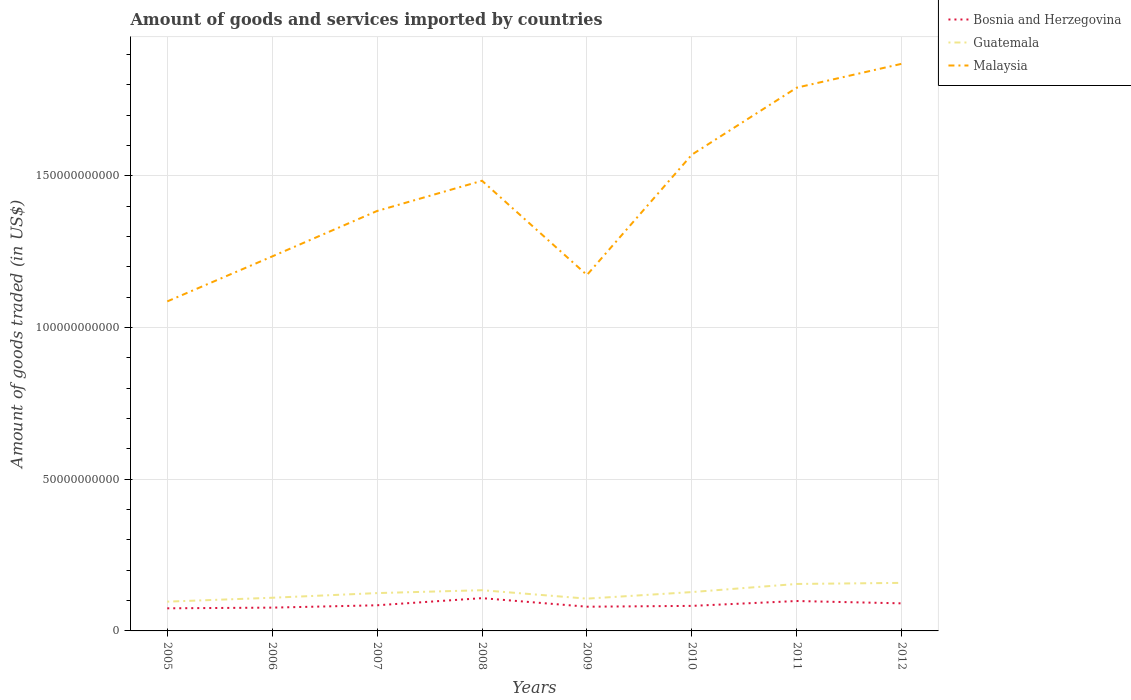Does the line corresponding to Malaysia intersect with the line corresponding to Guatemala?
Provide a short and direct response. No. Is the number of lines equal to the number of legend labels?
Give a very brief answer. Yes. Across all years, what is the maximum total amount of goods and services imported in Guatemala?
Your response must be concise. 9.65e+09. What is the total total amount of goods and services imported in Bosnia and Herzegovina in the graph?
Your answer should be compact. -1.40e+09. What is the difference between the highest and the second highest total amount of goods and services imported in Bosnia and Herzegovina?
Give a very brief answer. 3.35e+09. What is the difference between the highest and the lowest total amount of goods and services imported in Bosnia and Herzegovina?
Your response must be concise. 3. How many lines are there?
Ensure brevity in your answer.  3. How many years are there in the graph?
Offer a terse response. 8. What is the difference between two consecutive major ticks on the Y-axis?
Offer a very short reply. 5.00e+1. Does the graph contain grids?
Provide a short and direct response. Yes. How are the legend labels stacked?
Give a very brief answer. Vertical. What is the title of the graph?
Your answer should be very brief. Amount of goods and services imported by countries. Does "Gambia, The" appear as one of the legend labels in the graph?
Provide a short and direct response. No. What is the label or title of the X-axis?
Keep it short and to the point. Years. What is the label or title of the Y-axis?
Ensure brevity in your answer.  Amount of goods traded (in US$). What is the Amount of goods traded (in US$) in Bosnia and Herzegovina in 2005?
Provide a short and direct response. 7.45e+09. What is the Amount of goods traded (in US$) in Guatemala in 2005?
Offer a very short reply. 9.65e+09. What is the Amount of goods traded (in US$) of Malaysia in 2005?
Provide a short and direct response. 1.09e+11. What is the Amount of goods traded (in US$) in Bosnia and Herzegovina in 2006?
Give a very brief answer. 7.68e+09. What is the Amount of goods traded (in US$) of Guatemala in 2006?
Your response must be concise. 1.09e+1. What is the Amount of goods traded (in US$) in Malaysia in 2006?
Offer a very short reply. 1.23e+11. What is the Amount of goods traded (in US$) of Bosnia and Herzegovina in 2007?
Offer a terse response. 8.45e+09. What is the Amount of goods traded (in US$) of Guatemala in 2007?
Provide a succinct answer. 1.25e+1. What is the Amount of goods traded (in US$) of Malaysia in 2007?
Your response must be concise. 1.38e+11. What is the Amount of goods traded (in US$) in Bosnia and Herzegovina in 2008?
Offer a terse response. 1.08e+1. What is the Amount of goods traded (in US$) in Guatemala in 2008?
Your answer should be very brief. 1.34e+1. What is the Amount of goods traded (in US$) in Malaysia in 2008?
Offer a terse response. 1.48e+11. What is the Amount of goods traded (in US$) in Bosnia and Herzegovina in 2009?
Provide a short and direct response. 7.98e+09. What is the Amount of goods traded (in US$) of Guatemala in 2009?
Your response must be concise. 1.06e+1. What is the Amount of goods traded (in US$) of Malaysia in 2009?
Your answer should be very brief. 1.17e+11. What is the Amount of goods traded (in US$) of Bosnia and Herzegovina in 2010?
Offer a very short reply. 8.25e+09. What is the Amount of goods traded (in US$) in Guatemala in 2010?
Ensure brevity in your answer.  1.28e+1. What is the Amount of goods traded (in US$) of Malaysia in 2010?
Your response must be concise. 1.57e+11. What is the Amount of goods traded (in US$) of Bosnia and Herzegovina in 2011?
Provide a short and direct response. 9.86e+09. What is the Amount of goods traded (in US$) of Guatemala in 2011?
Provide a succinct answer. 1.55e+1. What is the Amount of goods traded (in US$) in Malaysia in 2011?
Your response must be concise. 1.79e+11. What is the Amount of goods traded (in US$) in Bosnia and Herzegovina in 2012?
Offer a very short reply. 9.09e+09. What is the Amount of goods traded (in US$) in Guatemala in 2012?
Ensure brevity in your answer.  1.58e+1. What is the Amount of goods traded (in US$) in Malaysia in 2012?
Provide a short and direct response. 1.87e+11. Across all years, what is the maximum Amount of goods traded (in US$) of Bosnia and Herzegovina?
Provide a short and direct response. 1.08e+1. Across all years, what is the maximum Amount of goods traded (in US$) in Guatemala?
Ensure brevity in your answer.  1.58e+1. Across all years, what is the maximum Amount of goods traded (in US$) of Malaysia?
Keep it short and to the point. 1.87e+11. Across all years, what is the minimum Amount of goods traded (in US$) in Bosnia and Herzegovina?
Provide a short and direct response. 7.45e+09. Across all years, what is the minimum Amount of goods traded (in US$) of Guatemala?
Offer a very short reply. 9.65e+09. Across all years, what is the minimum Amount of goods traded (in US$) of Malaysia?
Keep it short and to the point. 1.09e+11. What is the total Amount of goods traded (in US$) in Bosnia and Herzegovina in the graph?
Ensure brevity in your answer.  6.96e+1. What is the total Amount of goods traded (in US$) of Guatemala in the graph?
Make the answer very short. 1.01e+11. What is the total Amount of goods traded (in US$) of Malaysia in the graph?
Your answer should be very brief. 1.16e+12. What is the difference between the Amount of goods traded (in US$) in Bosnia and Herzegovina in 2005 and that in 2006?
Your answer should be compact. -2.25e+08. What is the difference between the Amount of goods traded (in US$) in Guatemala in 2005 and that in 2006?
Your response must be concise. -1.28e+09. What is the difference between the Amount of goods traded (in US$) of Malaysia in 2005 and that in 2006?
Offer a very short reply. -1.48e+1. What is the difference between the Amount of goods traded (in US$) of Bosnia and Herzegovina in 2005 and that in 2007?
Offer a terse response. -1.00e+09. What is the difference between the Amount of goods traded (in US$) in Guatemala in 2005 and that in 2007?
Offer a very short reply. -2.82e+09. What is the difference between the Amount of goods traded (in US$) in Malaysia in 2005 and that in 2007?
Offer a very short reply. -2.98e+1. What is the difference between the Amount of goods traded (in US$) in Bosnia and Herzegovina in 2005 and that in 2008?
Give a very brief answer. -3.35e+09. What is the difference between the Amount of goods traded (in US$) in Guatemala in 2005 and that in 2008?
Your response must be concise. -3.77e+09. What is the difference between the Amount of goods traded (in US$) in Malaysia in 2005 and that in 2008?
Ensure brevity in your answer.  -3.98e+1. What is the difference between the Amount of goods traded (in US$) of Bosnia and Herzegovina in 2005 and that in 2009?
Your answer should be very brief. -5.30e+08. What is the difference between the Amount of goods traded (in US$) of Guatemala in 2005 and that in 2009?
Make the answer very short. -9.93e+08. What is the difference between the Amount of goods traded (in US$) in Malaysia in 2005 and that in 2009?
Offer a very short reply. -8.71e+09. What is the difference between the Amount of goods traded (in US$) in Bosnia and Herzegovina in 2005 and that in 2010?
Ensure brevity in your answer.  -7.99e+08. What is the difference between the Amount of goods traded (in US$) of Guatemala in 2005 and that in 2010?
Provide a succinct answer. -3.16e+09. What is the difference between the Amount of goods traded (in US$) of Malaysia in 2005 and that in 2010?
Provide a short and direct response. -4.84e+1. What is the difference between the Amount of goods traded (in US$) in Bosnia and Herzegovina in 2005 and that in 2011?
Ensure brevity in your answer.  -2.40e+09. What is the difference between the Amount of goods traded (in US$) in Guatemala in 2005 and that in 2011?
Your response must be concise. -5.83e+09. What is the difference between the Amount of goods traded (in US$) in Malaysia in 2005 and that in 2011?
Ensure brevity in your answer.  -7.05e+1. What is the difference between the Amount of goods traded (in US$) of Bosnia and Herzegovina in 2005 and that in 2012?
Offer a terse response. -1.63e+09. What is the difference between the Amount of goods traded (in US$) in Guatemala in 2005 and that in 2012?
Your response must be concise. -6.19e+09. What is the difference between the Amount of goods traded (in US$) in Malaysia in 2005 and that in 2012?
Provide a short and direct response. -7.83e+1. What is the difference between the Amount of goods traded (in US$) in Bosnia and Herzegovina in 2006 and that in 2007?
Make the answer very short. -7.75e+08. What is the difference between the Amount of goods traded (in US$) of Guatemala in 2006 and that in 2007?
Ensure brevity in your answer.  -1.54e+09. What is the difference between the Amount of goods traded (in US$) in Malaysia in 2006 and that in 2007?
Your answer should be very brief. -1.50e+1. What is the difference between the Amount of goods traded (in US$) in Bosnia and Herzegovina in 2006 and that in 2008?
Keep it short and to the point. -3.12e+09. What is the difference between the Amount of goods traded (in US$) of Guatemala in 2006 and that in 2008?
Your answer should be very brief. -2.49e+09. What is the difference between the Amount of goods traded (in US$) in Malaysia in 2006 and that in 2008?
Provide a short and direct response. -2.49e+1. What is the difference between the Amount of goods traded (in US$) of Bosnia and Herzegovina in 2006 and that in 2009?
Offer a terse response. -3.05e+08. What is the difference between the Amount of goods traded (in US$) of Guatemala in 2006 and that in 2009?
Offer a terse response. 2.91e+08. What is the difference between the Amount of goods traded (in US$) in Malaysia in 2006 and that in 2009?
Make the answer very short. 6.12e+09. What is the difference between the Amount of goods traded (in US$) in Bosnia and Herzegovina in 2006 and that in 2010?
Offer a terse response. -5.74e+08. What is the difference between the Amount of goods traded (in US$) of Guatemala in 2006 and that in 2010?
Your response must be concise. -1.87e+09. What is the difference between the Amount of goods traded (in US$) in Malaysia in 2006 and that in 2010?
Make the answer very short. -3.36e+1. What is the difference between the Amount of goods traded (in US$) in Bosnia and Herzegovina in 2006 and that in 2011?
Keep it short and to the point. -2.18e+09. What is the difference between the Amount of goods traded (in US$) in Guatemala in 2006 and that in 2011?
Offer a very short reply. -4.55e+09. What is the difference between the Amount of goods traded (in US$) of Malaysia in 2006 and that in 2011?
Provide a succinct answer. -5.56e+1. What is the difference between the Amount of goods traded (in US$) of Bosnia and Herzegovina in 2006 and that in 2012?
Offer a very short reply. -1.41e+09. What is the difference between the Amount of goods traded (in US$) of Guatemala in 2006 and that in 2012?
Your answer should be compact. -4.90e+09. What is the difference between the Amount of goods traded (in US$) of Malaysia in 2006 and that in 2012?
Offer a terse response. -6.35e+1. What is the difference between the Amount of goods traded (in US$) of Bosnia and Herzegovina in 2007 and that in 2008?
Provide a succinct answer. -2.35e+09. What is the difference between the Amount of goods traded (in US$) of Guatemala in 2007 and that in 2008?
Make the answer very short. -9.51e+08. What is the difference between the Amount of goods traded (in US$) in Malaysia in 2007 and that in 2008?
Your answer should be compact. -9.96e+09. What is the difference between the Amount of goods traded (in US$) of Bosnia and Herzegovina in 2007 and that in 2009?
Offer a very short reply. 4.70e+08. What is the difference between the Amount of goods traded (in US$) in Guatemala in 2007 and that in 2009?
Provide a short and direct response. 1.83e+09. What is the difference between the Amount of goods traded (in US$) in Malaysia in 2007 and that in 2009?
Your response must be concise. 2.11e+1. What is the difference between the Amount of goods traded (in US$) of Bosnia and Herzegovina in 2007 and that in 2010?
Your answer should be compact. 2.01e+08. What is the difference between the Amount of goods traded (in US$) in Guatemala in 2007 and that in 2010?
Provide a succinct answer. -3.36e+08. What is the difference between the Amount of goods traded (in US$) in Malaysia in 2007 and that in 2010?
Provide a short and direct response. -1.86e+1. What is the difference between the Amount of goods traded (in US$) in Bosnia and Herzegovina in 2007 and that in 2011?
Give a very brief answer. -1.40e+09. What is the difference between the Amount of goods traded (in US$) of Guatemala in 2007 and that in 2011?
Offer a very short reply. -3.01e+09. What is the difference between the Amount of goods traded (in US$) in Malaysia in 2007 and that in 2011?
Offer a terse response. -4.07e+1. What is the difference between the Amount of goods traded (in US$) of Bosnia and Herzegovina in 2007 and that in 2012?
Your answer should be very brief. -6.34e+08. What is the difference between the Amount of goods traded (in US$) of Guatemala in 2007 and that in 2012?
Your answer should be very brief. -3.37e+09. What is the difference between the Amount of goods traded (in US$) in Malaysia in 2007 and that in 2012?
Provide a short and direct response. -4.85e+1. What is the difference between the Amount of goods traded (in US$) in Bosnia and Herzegovina in 2008 and that in 2009?
Your answer should be compact. 2.82e+09. What is the difference between the Amount of goods traded (in US$) of Guatemala in 2008 and that in 2009?
Provide a short and direct response. 2.78e+09. What is the difference between the Amount of goods traded (in US$) in Malaysia in 2008 and that in 2009?
Provide a short and direct response. 3.11e+1. What is the difference between the Amount of goods traded (in US$) of Bosnia and Herzegovina in 2008 and that in 2010?
Give a very brief answer. 2.55e+09. What is the difference between the Amount of goods traded (in US$) in Guatemala in 2008 and that in 2010?
Ensure brevity in your answer.  6.15e+08. What is the difference between the Amount of goods traded (in US$) of Malaysia in 2008 and that in 2010?
Make the answer very short. -8.60e+09. What is the difference between the Amount of goods traded (in US$) in Bosnia and Herzegovina in 2008 and that in 2011?
Keep it short and to the point. 9.45e+08. What is the difference between the Amount of goods traded (in US$) in Guatemala in 2008 and that in 2011?
Your answer should be compact. -2.06e+09. What is the difference between the Amount of goods traded (in US$) of Malaysia in 2008 and that in 2011?
Keep it short and to the point. -3.07e+1. What is the difference between the Amount of goods traded (in US$) in Bosnia and Herzegovina in 2008 and that in 2012?
Ensure brevity in your answer.  1.71e+09. What is the difference between the Amount of goods traded (in US$) in Guatemala in 2008 and that in 2012?
Your answer should be very brief. -2.42e+09. What is the difference between the Amount of goods traded (in US$) of Malaysia in 2008 and that in 2012?
Make the answer very short. -3.86e+1. What is the difference between the Amount of goods traded (in US$) in Bosnia and Herzegovina in 2009 and that in 2010?
Ensure brevity in your answer.  -2.69e+08. What is the difference between the Amount of goods traded (in US$) of Guatemala in 2009 and that in 2010?
Make the answer very short. -2.16e+09. What is the difference between the Amount of goods traded (in US$) of Malaysia in 2009 and that in 2010?
Provide a succinct answer. -3.97e+1. What is the difference between the Amount of goods traded (in US$) in Bosnia and Herzegovina in 2009 and that in 2011?
Offer a very short reply. -1.87e+09. What is the difference between the Amount of goods traded (in US$) of Guatemala in 2009 and that in 2011?
Make the answer very short. -4.84e+09. What is the difference between the Amount of goods traded (in US$) of Malaysia in 2009 and that in 2011?
Provide a short and direct response. -6.18e+1. What is the difference between the Amount of goods traded (in US$) of Bosnia and Herzegovina in 2009 and that in 2012?
Your answer should be compact. -1.10e+09. What is the difference between the Amount of goods traded (in US$) of Guatemala in 2009 and that in 2012?
Provide a succinct answer. -5.19e+09. What is the difference between the Amount of goods traded (in US$) in Malaysia in 2009 and that in 2012?
Provide a succinct answer. -6.96e+1. What is the difference between the Amount of goods traded (in US$) in Bosnia and Herzegovina in 2010 and that in 2011?
Your response must be concise. -1.61e+09. What is the difference between the Amount of goods traded (in US$) of Guatemala in 2010 and that in 2011?
Provide a short and direct response. -2.68e+09. What is the difference between the Amount of goods traded (in US$) of Malaysia in 2010 and that in 2011?
Ensure brevity in your answer.  -2.21e+1. What is the difference between the Amount of goods traded (in US$) in Bosnia and Herzegovina in 2010 and that in 2012?
Make the answer very short. -8.35e+08. What is the difference between the Amount of goods traded (in US$) in Guatemala in 2010 and that in 2012?
Your response must be concise. -3.03e+09. What is the difference between the Amount of goods traded (in US$) in Malaysia in 2010 and that in 2012?
Offer a terse response. -3.00e+1. What is the difference between the Amount of goods traded (in US$) in Bosnia and Herzegovina in 2011 and that in 2012?
Your answer should be very brief. 7.70e+08. What is the difference between the Amount of goods traded (in US$) in Guatemala in 2011 and that in 2012?
Offer a very short reply. -3.56e+08. What is the difference between the Amount of goods traded (in US$) in Malaysia in 2011 and that in 2012?
Your response must be concise. -7.86e+09. What is the difference between the Amount of goods traded (in US$) in Bosnia and Herzegovina in 2005 and the Amount of goods traded (in US$) in Guatemala in 2006?
Offer a terse response. -3.48e+09. What is the difference between the Amount of goods traded (in US$) of Bosnia and Herzegovina in 2005 and the Amount of goods traded (in US$) of Malaysia in 2006?
Your response must be concise. -1.16e+11. What is the difference between the Amount of goods traded (in US$) of Guatemala in 2005 and the Amount of goods traded (in US$) of Malaysia in 2006?
Offer a terse response. -1.14e+11. What is the difference between the Amount of goods traded (in US$) in Bosnia and Herzegovina in 2005 and the Amount of goods traded (in US$) in Guatemala in 2007?
Provide a succinct answer. -5.02e+09. What is the difference between the Amount of goods traded (in US$) of Bosnia and Herzegovina in 2005 and the Amount of goods traded (in US$) of Malaysia in 2007?
Offer a very short reply. -1.31e+11. What is the difference between the Amount of goods traded (in US$) of Guatemala in 2005 and the Amount of goods traded (in US$) of Malaysia in 2007?
Keep it short and to the point. -1.29e+11. What is the difference between the Amount of goods traded (in US$) of Bosnia and Herzegovina in 2005 and the Amount of goods traded (in US$) of Guatemala in 2008?
Your answer should be very brief. -5.97e+09. What is the difference between the Amount of goods traded (in US$) in Bosnia and Herzegovina in 2005 and the Amount of goods traded (in US$) in Malaysia in 2008?
Your response must be concise. -1.41e+11. What is the difference between the Amount of goods traded (in US$) of Guatemala in 2005 and the Amount of goods traded (in US$) of Malaysia in 2008?
Make the answer very short. -1.39e+11. What is the difference between the Amount of goods traded (in US$) in Bosnia and Herzegovina in 2005 and the Amount of goods traded (in US$) in Guatemala in 2009?
Offer a terse response. -3.19e+09. What is the difference between the Amount of goods traded (in US$) in Bosnia and Herzegovina in 2005 and the Amount of goods traded (in US$) in Malaysia in 2009?
Offer a very short reply. -1.10e+11. What is the difference between the Amount of goods traded (in US$) of Guatemala in 2005 and the Amount of goods traded (in US$) of Malaysia in 2009?
Give a very brief answer. -1.08e+11. What is the difference between the Amount of goods traded (in US$) of Bosnia and Herzegovina in 2005 and the Amount of goods traded (in US$) of Guatemala in 2010?
Make the answer very short. -5.35e+09. What is the difference between the Amount of goods traded (in US$) in Bosnia and Herzegovina in 2005 and the Amount of goods traded (in US$) in Malaysia in 2010?
Give a very brief answer. -1.50e+11. What is the difference between the Amount of goods traded (in US$) of Guatemala in 2005 and the Amount of goods traded (in US$) of Malaysia in 2010?
Make the answer very short. -1.47e+11. What is the difference between the Amount of goods traded (in US$) of Bosnia and Herzegovina in 2005 and the Amount of goods traded (in US$) of Guatemala in 2011?
Offer a terse response. -8.03e+09. What is the difference between the Amount of goods traded (in US$) in Bosnia and Herzegovina in 2005 and the Amount of goods traded (in US$) in Malaysia in 2011?
Offer a terse response. -1.72e+11. What is the difference between the Amount of goods traded (in US$) in Guatemala in 2005 and the Amount of goods traded (in US$) in Malaysia in 2011?
Your answer should be compact. -1.69e+11. What is the difference between the Amount of goods traded (in US$) of Bosnia and Herzegovina in 2005 and the Amount of goods traded (in US$) of Guatemala in 2012?
Provide a succinct answer. -8.38e+09. What is the difference between the Amount of goods traded (in US$) of Bosnia and Herzegovina in 2005 and the Amount of goods traded (in US$) of Malaysia in 2012?
Offer a very short reply. -1.79e+11. What is the difference between the Amount of goods traded (in US$) in Guatemala in 2005 and the Amount of goods traded (in US$) in Malaysia in 2012?
Offer a terse response. -1.77e+11. What is the difference between the Amount of goods traded (in US$) of Bosnia and Herzegovina in 2006 and the Amount of goods traded (in US$) of Guatemala in 2007?
Provide a succinct answer. -4.79e+09. What is the difference between the Amount of goods traded (in US$) of Bosnia and Herzegovina in 2006 and the Amount of goods traded (in US$) of Malaysia in 2007?
Your answer should be compact. -1.31e+11. What is the difference between the Amount of goods traded (in US$) in Guatemala in 2006 and the Amount of goods traded (in US$) in Malaysia in 2007?
Offer a terse response. -1.27e+11. What is the difference between the Amount of goods traded (in US$) in Bosnia and Herzegovina in 2006 and the Amount of goods traded (in US$) in Guatemala in 2008?
Your answer should be compact. -5.74e+09. What is the difference between the Amount of goods traded (in US$) in Bosnia and Herzegovina in 2006 and the Amount of goods traded (in US$) in Malaysia in 2008?
Offer a terse response. -1.41e+11. What is the difference between the Amount of goods traded (in US$) in Guatemala in 2006 and the Amount of goods traded (in US$) in Malaysia in 2008?
Make the answer very short. -1.37e+11. What is the difference between the Amount of goods traded (in US$) in Bosnia and Herzegovina in 2006 and the Amount of goods traded (in US$) in Guatemala in 2009?
Offer a terse response. -2.96e+09. What is the difference between the Amount of goods traded (in US$) of Bosnia and Herzegovina in 2006 and the Amount of goods traded (in US$) of Malaysia in 2009?
Make the answer very short. -1.10e+11. What is the difference between the Amount of goods traded (in US$) of Guatemala in 2006 and the Amount of goods traded (in US$) of Malaysia in 2009?
Give a very brief answer. -1.06e+11. What is the difference between the Amount of goods traded (in US$) in Bosnia and Herzegovina in 2006 and the Amount of goods traded (in US$) in Guatemala in 2010?
Make the answer very short. -5.13e+09. What is the difference between the Amount of goods traded (in US$) of Bosnia and Herzegovina in 2006 and the Amount of goods traded (in US$) of Malaysia in 2010?
Your response must be concise. -1.49e+11. What is the difference between the Amount of goods traded (in US$) of Guatemala in 2006 and the Amount of goods traded (in US$) of Malaysia in 2010?
Keep it short and to the point. -1.46e+11. What is the difference between the Amount of goods traded (in US$) of Bosnia and Herzegovina in 2006 and the Amount of goods traded (in US$) of Guatemala in 2011?
Your response must be concise. -7.80e+09. What is the difference between the Amount of goods traded (in US$) in Bosnia and Herzegovina in 2006 and the Amount of goods traded (in US$) in Malaysia in 2011?
Your response must be concise. -1.71e+11. What is the difference between the Amount of goods traded (in US$) in Guatemala in 2006 and the Amount of goods traded (in US$) in Malaysia in 2011?
Your response must be concise. -1.68e+11. What is the difference between the Amount of goods traded (in US$) of Bosnia and Herzegovina in 2006 and the Amount of goods traded (in US$) of Guatemala in 2012?
Offer a very short reply. -8.16e+09. What is the difference between the Amount of goods traded (in US$) of Bosnia and Herzegovina in 2006 and the Amount of goods traded (in US$) of Malaysia in 2012?
Provide a short and direct response. -1.79e+11. What is the difference between the Amount of goods traded (in US$) in Guatemala in 2006 and the Amount of goods traded (in US$) in Malaysia in 2012?
Keep it short and to the point. -1.76e+11. What is the difference between the Amount of goods traded (in US$) in Bosnia and Herzegovina in 2007 and the Amount of goods traded (in US$) in Guatemala in 2008?
Provide a short and direct response. -4.97e+09. What is the difference between the Amount of goods traded (in US$) in Bosnia and Herzegovina in 2007 and the Amount of goods traded (in US$) in Malaysia in 2008?
Give a very brief answer. -1.40e+11. What is the difference between the Amount of goods traded (in US$) of Guatemala in 2007 and the Amount of goods traded (in US$) of Malaysia in 2008?
Provide a short and direct response. -1.36e+11. What is the difference between the Amount of goods traded (in US$) of Bosnia and Herzegovina in 2007 and the Amount of goods traded (in US$) of Guatemala in 2009?
Give a very brief answer. -2.19e+09. What is the difference between the Amount of goods traded (in US$) of Bosnia and Herzegovina in 2007 and the Amount of goods traded (in US$) of Malaysia in 2009?
Your answer should be very brief. -1.09e+11. What is the difference between the Amount of goods traded (in US$) of Guatemala in 2007 and the Amount of goods traded (in US$) of Malaysia in 2009?
Offer a very short reply. -1.05e+11. What is the difference between the Amount of goods traded (in US$) of Bosnia and Herzegovina in 2007 and the Amount of goods traded (in US$) of Guatemala in 2010?
Your answer should be very brief. -4.35e+09. What is the difference between the Amount of goods traded (in US$) of Bosnia and Herzegovina in 2007 and the Amount of goods traded (in US$) of Malaysia in 2010?
Give a very brief answer. -1.49e+11. What is the difference between the Amount of goods traded (in US$) in Guatemala in 2007 and the Amount of goods traded (in US$) in Malaysia in 2010?
Your answer should be compact. -1.45e+11. What is the difference between the Amount of goods traded (in US$) of Bosnia and Herzegovina in 2007 and the Amount of goods traded (in US$) of Guatemala in 2011?
Your response must be concise. -7.03e+09. What is the difference between the Amount of goods traded (in US$) in Bosnia and Herzegovina in 2007 and the Amount of goods traded (in US$) in Malaysia in 2011?
Ensure brevity in your answer.  -1.71e+11. What is the difference between the Amount of goods traded (in US$) of Guatemala in 2007 and the Amount of goods traded (in US$) of Malaysia in 2011?
Provide a succinct answer. -1.67e+11. What is the difference between the Amount of goods traded (in US$) in Bosnia and Herzegovina in 2007 and the Amount of goods traded (in US$) in Guatemala in 2012?
Provide a short and direct response. -7.38e+09. What is the difference between the Amount of goods traded (in US$) of Bosnia and Herzegovina in 2007 and the Amount of goods traded (in US$) of Malaysia in 2012?
Your response must be concise. -1.78e+11. What is the difference between the Amount of goods traded (in US$) in Guatemala in 2007 and the Amount of goods traded (in US$) in Malaysia in 2012?
Ensure brevity in your answer.  -1.74e+11. What is the difference between the Amount of goods traded (in US$) in Bosnia and Herzegovina in 2008 and the Amount of goods traded (in US$) in Guatemala in 2009?
Give a very brief answer. 1.60e+08. What is the difference between the Amount of goods traded (in US$) of Bosnia and Herzegovina in 2008 and the Amount of goods traded (in US$) of Malaysia in 2009?
Provide a short and direct response. -1.07e+11. What is the difference between the Amount of goods traded (in US$) in Guatemala in 2008 and the Amount of goods traded (in US$) in Malaysia in 2009?
Give a very brief answer. -1.04e+11. What is the difference between the Amount of goods traded (in US$) of Bosnia and Herzegovina in 2008 and the Amount of goods traded (in US$) of Guatemala in 2010?
Your answer should be compact. -2.00e+09. What is the difference between the Amount of goods traded (in US$) in Bosnia and Herzegovina in 2008 and the Amount of goods traded (in US$) in Malaysia in 2010?
Offer a very short reply. -1.46e+11. What is the difference between the Amount of goods traded (in US$) in Guatemala in 2008 and the Amount of goods traded (in US$) in Malaysia in 2010?
Offer a terse response. -1.44e+11. What is the difference between the Amount of goods traded (in US$) in Bosnia and Herzegovina in 2008 and the Amount of goods traded (in US$) in Guatemala in 2011?
Offer a very short reply. -4.68e+09. What is the difference between the Amount of goods traded (in US$) in Bosnia and Herzegovina in 2008 and the Amount of goods traded (in US$) in Malaysia in 2011?
Keep it short and to the point. -1.68e+11. What is the difference between the Amount of goods traded (in US$) of Guatemala in 2008 and the Amount of goods traded (in US$) of Malaysia in 2011?
Give a very brief answer. -1.66e+11. What is the difference between the Amount of goods traded (in US$) of Bosnia and Herzegovina in 2008 and the Amount of goods traded (in US$) of Guatemala in 2012?
Give a very brief answer. -5.03e+09. What is the difference between the Amount of goods traded (in US$) of Bosnia and Herzegovina in 2008 and the Amount of goods traded (in US$) of Malaysia in 2012?
Give a very brief answer. -1.76e+11. What is the difference between the Amount of goods traded (in US$) in Guatemala in 2008 and the Amount of goods traded (in US$) in Malaysia in 2012?
Offer a terse response. -1.74e+11. What is the difference between the Amount of goods traded (in US$) in Bosnia and Herzegovina in 2009 and the Amount of goods traded (in US$) in Guatemala in 2010?
Provide a short and direct response. -4.82e+09. What is the difference between the Amount of goods traded (in US$) of Bosnia and Herzegovina in 2009 and the Amount of goods traded (in US$) of Malaysia in 2010?
Offer a very short reply. -1.49e+11. What is the difference between the Amount of goods traded (in US$) in Guatemala in 2009 and the Amount of goods traded (in US$) in Malaysia in 2010?
Offer a very short reply. -1.46e+11. What is the difference between the Amount of goods traded (in US$) in Bosnia and Herzegovina in 2009 and the Amount of goods traded (in US$) in Guatemala in 2011?
Offer a terse response. -7.50e+09. What is the difference between the Amount of goods traded (in US$) in Bosnia and Herzegovina in 2009 and the Amount of goods traded (in US$) in Malaysia in 2011?
Your answer should be compact. -1.71e+11. What is the difference between the Amount of goods traded (in US$) of Guatemala in 2009 and the Amount of goods traded (in US$) of Malaysia in 2011?
Your answer should be very brief. -1.68e+11. What is the difference between the Amount of goods traded (in US$) of Bosnia and Herzegovina in 2009 and the Amount of goods traded (in US$) of Guatemala in 2012?
Make the answer very short. -7.85e+09. What is the difference between the Amount of goods traded (in US$) of Bosnia and Herzegovina in 2009 and the Amount of goods traded (in US$) of Malaysia in 2012?
Your response must be concise. -1.79e+11. What is the difference between the Amount of goods traded (in US$) in Guatemala in 2009 and the Amount of goods traded (in US$) in Malaysia in 2012?
Ensure brevity in your answer.  -1.76e+11. What is the difference between the Amount of goods traded (in US$) in Bosnia and Herzegovina in 2010 and the Amount of goods traded (in US$) in Guatemala in 2011?
Your answer should be compact. -7.23e+09. What is the difference between the Amount of goods traded (in US$) of Bosnia and Herzegovina in 2010 and the Amount of goods traded (in US$) of Malaysia in 2011?
Offer a very short reply. -1.71e+11. What is the difference between the Amount of goods traded (in US$) of Guatemala in 2010 and the Amount of goods traded (in US$) of Malaysia in 2011?
Your answer should be compact. -1.66e+11. What is the difference between the Amount of goods traded (in US$) in Bosnia and Herzegovina in 2010 and the Amount of goods traded (in US$) in Guatemala in 2012?
Ensure brevity in your answer.  -7.58e+09. What is the difference between the Amount of goods traded (in US$) in Bosnia and Herzegovina in 2010 and the Amount of goods traded (in US$) in Malaysia in 2012?
Your response must be concise. -1.79e+11. What is the difference between the Amount of goods traded (in US$) of Guatemala in 2010 and the Amount of goods traded (in US$) of Malaysia in 2012?
Your answer should be compact. -1.74e+11. What is the difference between the Amount of goods traded (in US$) of Bosnia and Herzegovina in 2011 and the Amount of goods traded (in US$) of Guatemala in 2012?
Keep it short and to the point. -5.98e+09. What is the difference between the Amount of goods traded (in US$) in Bosnia and Herzegovina in 2011 and the Amount of goods traded (in US$) in Malaysia in 2012?
Your answer should be very brief. -1.77e+11. What is the difference between the Amount of goods traded (in US$) of Guatemala in 2011 and the Amount of goods traded (in US$) of Malaysia in 2012?
Your answer should be very brief. -1.71e+11. What is the average Amount of goods traded (in US$) in Bosnia and Herzegovina per year?
Keep it short and to the point. 8.70e+09. What is the average Amount of goods traded (in US$) of Guatemala per year?
Keep it short and to the point. 1.27e+1. What is the average Amount of goods traded (in US$) of Malaysia per year?
Your response must be concise. 1.45e+11. In the year 2005, what is the difference between the Amount of goods traded (in US$) in Bosnia and Herzegovina and Amount of goods traded (in US$) in Guatemala?
Provide a short and direct response. -2.20e+09. In the year 2005, what is the difference between the Amount of goods traded (in US$) of Bosnia and Herzegovina and Amount of goods traded (in US$) of Malaysia?
Your answer should be compact. -1.01e+11. In the year 2005, what is the difference between the Amount of goods traded (in US$) of Guatemala and Amount of goods traded (in US$) of Malaysia?
Offer a terse response. -9.90e+1. In the year 2006, what is the difference between the Amount of goods traded (in US$) in Bosnia and Herzegovina and Amount of goods traded (in US$) in Guatemala?
Provide a succinct answer. -3.25e+09. In the year 2006, what is the difference between the Amount of goods traded (in US$) of Bosnia and Herzegovina and Amount of goods traded (in US$) of Malaysia?
Keep it short and to the point. -1.16e+11. In the year 2006, what is the difference between the Amount of goods traded (in US$) in Guatemala and Amount of goods traded (in US$) in Malaysia?
Make the answer very short. -1.13e+11. In the year 2007, what is the difference between the Amount of goods traded (in US$) of Bosnia and Herzegovina and Amount of goods traded (in US$) of Guatemala?
Your answer should be very brief. -4.02e+09. In the year 2007, what is the difference between the Amount of goods traded (in US$) in Bosnia and Herzegovina and Amount of goods traded (in US$) in Malaysia?
Keep it short and to the point. -1.30e+11. In the year 2007, what is the difference between the Amount of goods traded (in US$) of Guatemala and Amount of goods traded (in US$) of Malaysia?
Make the answer very short. -1.26e+11. In the year 2008, what is the difference between the Amount of goods traded (in US$) in Bosnia and Herzegovina and Amount of goods traded (in US$) in Guatemala?
Offer a very short reply. -2.62e+09. In the year 2008, what is the difference between the Amount of goods traded (in US$) in Bosnia and Herzegovina and Amount of goods traded (in US$) in Malaysia?
Keep it short and to the point. -1.38e+11. In the year 2008, what is the difference between the Amount of goods traded (in US$) of Guatemala and Amount of goods traded (in US$) of Malaysia?
Your response must be concise. -1.35e+11. In the year 2009, what is the difference between the Amount of goods traded (in US$) in Bosnia and Herzegovina and Amount of goods traded (in US$) in Guatemala?
Your answer should be compact. -2.66e+09. In the year 2009, what is the difference between the Amount of goods traded (in US$) of Bosnia and Herzegovina and Amount of goods traded (in US$) of Malaysia?
Provide a short and direct response. -1.09e+11. In the year 2009, what is the difference between the Amount of goods traded (in US$) of Guatemala and Amount of goods traded (in US$) of Malaysia?
Make the answer very short. -1.07e+11. In the year 2010, what is the difference between the Amount of goods traded (in US$) in Bosnia and Herzegovina and Amount of goods traded (in US$) in Guatemala?
Ensure brevity in your answer.  -4.55e+09. In the year 2010, what is the difference between the Amount of goods traded (in US$) in Bosnia and Herzegovina and Amount of goods traded (in US$) in Malaysia?
Give a very brief answer. -1.49e+11. In the year 2010, what is the difference between the Amount of goods traded (in US$) in Guatemala and Amount of goods traded (in US$) in Malaysia?
Your answer should be very brief. -1.44e+11. In the year 2011, what is the difference between the Amount of goods traded (in US$) of Bosnia and Herzegovina and Amount of goods traded (in US$) of Guatemala?
Your answer should be very brief. -5.62e+09. In the year 2011, what is the difference between the Amount of goods traded (in US$) in Bosnia and Herzegovina and Amount of goods traded (in US$) in Malaysia?
Ensure brevity in your answer.  -1.69e+11. In the year 2011, what is the difference between the Amount of goods traded (in US$) of Guatemala and Amount of goods traded (in US$) of Malaysia?
Ensure brevity in your answer.  -1.64e+11. In the year 2012, what is the difference between the Amount of goods traded (in US$) in Bosnia and Herzegovina and Amount of goods traded (in US$) in Guatemala?
Offer a terse response. -6.75e+09. In the year 2012, what is the difference between the Amount of goods traded (in US$) in Bosnia and Herzegovina and Amount of goods traded (in US$) in Malaysia?
Give a very brief answer. -1.78e+11. In the year 2012, what is the difference between the Amount of goods traded (in US$) of Guatemala and Amount of goods traded (in US$) of Malaysia?
Offer a terse response. -1.71e+11. What is the ratio of the Amount of goods traded (in US$) of Bosnia and Herzegovina in 2005 to that in 2006?
Your answer should be very brief. 0.97. What is the ratio of the Amount of goods traded (in US$) of Guatemala in 2005 to that in 2006?
Give a very brief answer. 0.88. What is the ratio of the Amount of goods traded (in US$) in Malaysia in 2005 to that in 2006?
Provide a short and direct response. 0.88. What is the ratio of the Amount of goods traded (in US$) of Bosnia and Herzegovina in 2005 to that in 2007?
Your answer should be compact. 0.88. What is the ratio of the Amount of goods traded (in US$) in Guatemala in 2005 to that in 2007?
Offer a terse response. 0.77. What is the ratio of the Amount of goods traded (in US$) of Malaysia in 2005 to that in 2007?
Your answer should be compact. 0.78. What is the ratio of the Amount of goods traded (in US$) of Bosnia and Herzegovina in 2005 to that in 2008?
Offer a terse response. 0.69. What is the ratio of the Amount of goods traded (in US$) in Guatemala in 2005 to that in 2008?
Your answer should be compact. 0.72. What is the ratio of the Amount of goods traded (in US$) in Malaysia in 2005 to that in 2008?
Offer a very short reply. 0.73. What is the ratio of the Amount of goods traded (in US$) of Bosnia and Herzegovina in 2005 to that in 2009?
Keep it short and to the point. 0.93. What is the ratio of the Amount of goods traded (in US$) in Guatemala in 2005 to that in 2009?
Ensure brevity in your answer.  0.91. What is the ratio of the Amount of goods traded (in US$) in Malaysia in 2005 to that in 2009?
Provide a succinct answer. 0.93. What is the ratio of the Amount of goods traded (in US$) in Bosnia and Herzegovina in 2005 to that in 2010?
Provide a succinct answer. 0.9. What is the ratio of the Amount of goods traded (in US$) in Guatemala in 2005 to that in 2010?
Provide a succinct answer. 0.75. What is the ratio of the Amount of goods traded (in US$) in Malaysia in 2005 to that in 2010?
Make the answer very short. 0.69. What is the ratio of the Amount of goods traded (in US$) in Bosnia and Herzegovina in 2005 to that in 2011?
Ensure brevity in your answer.  0.76. What is the ratio of the Amount of goods traded (in US$) in Guatemala in 2005 to that in 2011?
Provide a succinct answer. 0.62. What is the ratio of the Amount of goods traded (in US$) in Malaysia in 2005 to that in 2011?
Your response must be concise. 0.61. What is the ratio of the Amount of goods traded (in US$) in Bosnia and Herzegovina in 2005 to that in 2012?
Keep it short and to the point. 0.82. What is the ratio of the Amount of goods traded (in US$) of Guatemala in 2005 to that in 2012?
Give a very brief answer. 0.61. What is the ratio of the Amount of goods traded (in US$) of Malaysia in 2005 to that in 2012?
Provide a short and direct response. 0.58. What is the ratio of the Amount of goods traded (in US$) in Bosnia and Herzegovina in 2006 to that in 2007?
Provide a short and direct response. 0.91. What is the ratio of the Amount of goods traded (in US$) in Guatemala in 2006 to that in 2007?
Your response must be concise. 0.88. What is the ratio of the Amount of goods traded (in US$) of Malaysia in 2006 to that in 2007?
Keep it short and to the point. 0.89. What is the ratio of the Amount of goods traded (in US$) in Bosnia and Herzegovina in 2006 to that in 2008?
Your response must be concise. 0.71. What is the ratio of the Amount of goods traded (in US$) in Guatemala in 2006 to that in 2008?
Offer a very short reply. 0.81. What is the ratio of the Amount of goods traded (in US$) of Malaysia in 2006 to that in 2008?
Provide a succinct answer. 0.83. What is the ratio of the Amount of goods traded (in US$) in Bosnia and Herzegovina in 2006 to that in 2009?
Your answer should be very brief. 0.96. What is the ratio of the Amount of goods traded (in US$) in Guatemala in 2006 to that in 2009?
Your response must be concise. 1.03. What is the ratio of the Amount of goods traded (in US$) in Malaysia in 2006 to that in 2009?
Make the answer very short. 1.05. What is the ratio of the Amount of goods traded (in US$) in Bosnia and Herzegovina in 2006 to that in 2010?
Your answer should be compact. 0.93. What is the ratio of the Amount of goods traded (in US$) of Guatemala in 2006 to that in 2010?
Keep it short and to the point. 0.85. What is the ratio of the Amount of goods traded (in US$) in Malaysia in 2006 to that in 2010?
Keep it short and to the point. 0.79. What is the ratio of the Amount of goods traded (in US$) in Bosnia and Herzegovina in 2006 to that in 2011?
Your answer should be very brief. 0.78. What is the ratio of the Amount of goods traded (in US$) in Guatemala in 2006 to that in 2011?
Your answer should be compact. 0.71. What is the ratio of the Amount of goods traded (in US$) in Malaysia in 2006 to that in 2011?
Provide a short and direct response. 0.69. What is the ratio of the Amount of goods traded (in US$) of Bosnia and Herzegovina in 2006 to that in 2012?
Make the answer very short. 0.84. What is the ratio of the Amount of goods traded (in US$) in Guatemala in 2006 to that in 2012?
Offer a terse response. 0.69. What is the ratio of the Amount of goods traded (in US$) of Malaysia in 2006 to that in 2012?
Offer a very short reply. 0.66. What is the ratio of the Amount of goods traded (in US$) in Bosnia and Herzegovina in 2007 to that in 2008?
Your answer should be compact. 0.78. What is the ratio of the Amount of goods traded (in US$) of Guatemala in 2007 to that in 2008?
Provide a short and direct response. 0.93. What is the ratio of the Amount of goods traded (in US$) in Malaysia in 2007 to that in 2008?
Ensure brevity in your answer.  0.93. What is the ratio of the Amount of goods traded (in US$) in Bosnia and Herzegovina in 2007 to that in 2009?
Give a very brief answer. 1.06. What is the ratio of the Amount of goods traded (in US$) in Guatemala in 2007 to that in 2009?
Your response must be concise. 1.17. What is the ratio of the Amount of goods traded (in US$) of Malaysia in 2007 to that in 2009?
Make the answer very short. 1.18. What is the ratio of the Amount of goods traded (in US$) in Bosnia and Herzegovina in 2007 to that in 2010?
Your answer should be compact. 1.02. What is the ratio of the Amount of goods traded (in US$) of Guatemala in 2007 to that in 2010?
Keep it short and to the point. 0.97. What is the ratio of the Amount of goods traded (in US$) of Malaysia in 2007 to that in 2010?
Give a very brief answer. 0.88. What is the ratio of the Amount of goods traded (in US$) in Bosnia and Herzegovina in 2007 to that in 2011?
Give a very brief answer. 0.86. What is the ratio of the Amount of goods traded (in US$) of Guatemala in 2007 to that in 2011?
Your answer should be very brief. 0.81. What is the ratio of the Amount of goods traded (in US$) of Malaysia in 2007 to that in 2011?
Offer a terse response. 0.77. What is the ratio of the Amount of goods traded (in US$) in Bosnia and Herzegovina in 2007 to that in 2012?
Provide a succinct answer. 0.93. What is the ratio of the Amount of goods traded (in US$) of Guatemala in 2007 to that in 2012?
Ensure brevity in your answer.  0.79. What is the ratio of the Amount of goods traded (in US$) of Malaysia in 2007 to that in 2012?
Provide a succinct answer. 0.74. What is the ratio of the Amount of goods traded (in US$) in Bosnia and Herzegovina in 2008 to that in 2009?
Your answer should be very brief. 1.35. What is the ratio of the Amount of goods traded (in US$) in Guatemala in 2008 to that in 2009?
Offer a very short reply. 1.26. What is the ratio of the Amount of goods traded (in US$) of Malaysia in 2008 to that in 2009?
Offer a terse response. 1.26. What is the ratio of the Amount of goods traded (in US$) in Bosnia and Herzegovina in 2008 to that in 2010?
Your response must be concise. 1.31. What is the ratio of the Amount of goods traded (in US$) of Guatemala in 2008 to that in 2010?
Ensure brevity in your answer.  1.05. What is the ratio of the Amount of goods traded (in US$) of Malaysia in 2008 to that in 2010?
Your answer should be very brief. 0.95. What is the ratio of the Amount of goods traded (in US$) in Bosnia and Herzegovina in 2008 to that in 2011?
Keep it short and to the point. 1.1. What is the ratio of the Amount of goods traded (in US$) in Guatemala in 2008 to that in 2011?
Make the answer very short. 0.87. What is the ratio of the Amount of goods traded (in US$) of Malaysia in 2008 to that in 2011?
Keep it short and to the point. 0.83. What is the ratio of the Amount of goods traded (in US$) of Bosnia and Herzegovina in 2008 to that in 2012?
Make the answer very short. 1.19. What is the ratio of the Amount of goods traded (in US$) of Guatemala in 2008 to that in 2012?
Your answer should be very brief. 0.85. What is the ratio of the Amount of goods traded (in US$) in Malaysia in 2008 to that in 2012?
Give a very brief answer. 0.79. What is the ratio of the Amount of goods traded (in US$) of Bosnia and Herzegovina in 2009 to that in 2010?
Give a very brief answer. 0.97. What is the ratio of the Amount of goods traded (in US$) of Guatemala in 2009 to that in 2010?
Keep it short and to the point. 0.83. What is the ratio of the Amount of goods traded (in US$) in Malaysia in 2009 to that in 2010?
Provide a succinct answer. 0.75. What is the ratio of the Amount of goods traded (in US$) of Bosnia and Herzegovina in 2009 to that in 2011?
Your answer should be very brief. 0.81. What is the ratio of the Amount of goods traded (in US$) of Guatemala in 2009 to that in 2011?
Offer a very short reply. 0.69. What is the ratio of the Amount of goods traded (in US$) of Malaysia in 2009 to that in 2011?
Offer a terse response. 0.66. What is the ratio of the Amount of goods traded (in US$) in Bosnia and Herzegovina in 2009 to that in 2012?
Offer a terse response. 0.88. What is the ratio of the Amount of goods traded (in US$) in Guatemala in 2009 to that in 2012?
Keep it short and to the point. 0.67. What is the ratio of the Amount of goods traded (in US$) of Malaysia in 2009 to that in 2012?
Keep it short and to the point. 0.63. What is the ratio of the Amount of goods traded (in US$) in Bosnia and Herzegovina in 2010 to that in 2011?
Offer a very short reply. 0.84. What is the ratio of the Amount of goods traded (in US$) in Guatemala in 2010 to that in 2011?
Your answer should be compact. 0.83. What is the ratio of the Amount of goods traded (in US$) of Malaysia in 2010 to that in 2011?
Your response must be concise. 0.88. What is the ratio of the Amount of goods traded (in US$) of Bosnia and Herzegovina in 2010 to that in 2012?
Provide a succinct answer. 0.91. What is the ratio of the Amount of goods traded (in US$) in Guatemala in 2010 to that in 2012?
Offer a very short reply. 0.81. What is the ratio of the Amount of goods traded (in US$) of Malaysia in 2010 to that in 2012?
Give a very brief answer. 0.84. What is the ratio of the Amount of goods traded (in US$) in Bosnia and Herzegovina in 2011 to that in 2012?
Keep it short and to the point. 1.08. What is the ratio of the Amount of goods traded (in US$) in Guatemala in 2011 to that in 2012?
Offer a terse response. 0.98. What is the ratio of the Amount of goods traded (in US$) in Malaysia in 2011 to that in 2012?
Your answer should be compact. 0.96. What is the difference between the highest and the second highest Amount of goods traded (in US$) of Bosnia and Herzegovina?
Your answer should be very brief. 9.45e+08. What is the difference between the highest and the second highest Amount of goods traded (in US$) of Guatemala?
Offer a very short reply. 3.56e+08. What is the difference between the highest and the second highest Amount of goods traded (in US$) in Malaysia?
Your response must be concise. 7.86e+09. What is the difference between the highest and the lowest Amount of goods traded (in US$) in Bosnia and Herzegovina?
Your response must be concise. 3.35e+09. What is the difference between the highest and the lowest Amount of goods traded (in US$) of Guatemala?
Make the answer very short. 6.19e+09. What is the difference between the highest and the lowest Amount of goods traded (in US$) of Malaysia?
Your response must be concise. 7.83e+1. 